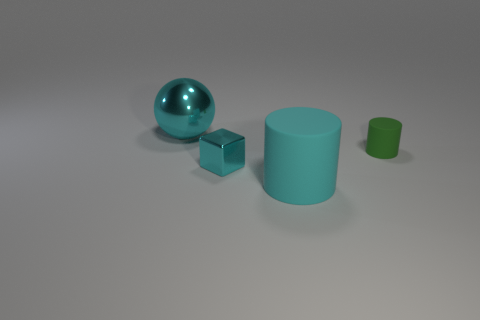Add 3 small cyan cubes. How many objects exist? 7 Subtract all cubes. How many objects are left? 3 Subtract 1 green cylinders. How many objects are left? 3 Subtract all small red balls. Subtract all big things. How many objects are left? 2 Add 2 green things. How many green things are left? 3 Add 2 tiny cyan shiny things. How many tiny cyan shiny things exist? 3 